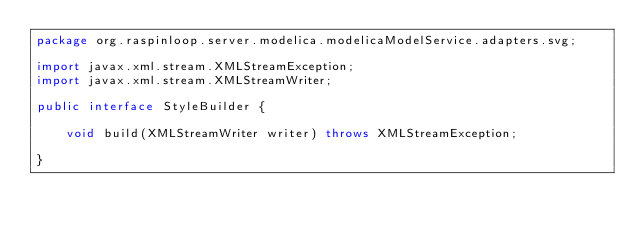<code> <loc_0><loc_0><loc_500><loc_500><_Java_>package org.raspinloop.server.modelica.modelicaModelService.adapters.svg;

import javax.xml.stream.XMLStreamException;
import javax.xml.stream.XMLStreamWriter;

public interface StyleBuilder {

	void build(XMLStreamWriter writer) throws XMLStreamException;

}
</code> 